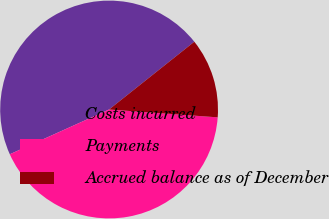<chart> <loc_0><loc_0><loc_500><loc_500><pie_chart><fcel>Costs incurred<fcel>Payments<fcel>Accrued balance as of December<nl><fcel>46.05%<fcel>42.11%<fcel>11.84%<nl></chart> 